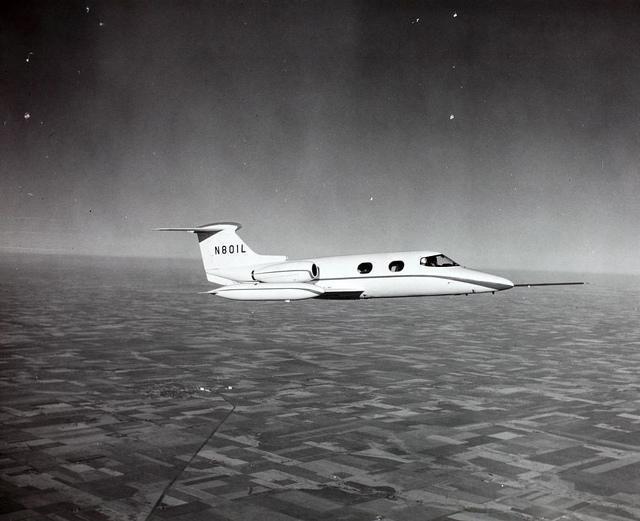How many airplanes can you see?
Give a very brief answer. 1. How many big chairs are in the image?
Give a very brief answer. 0. 